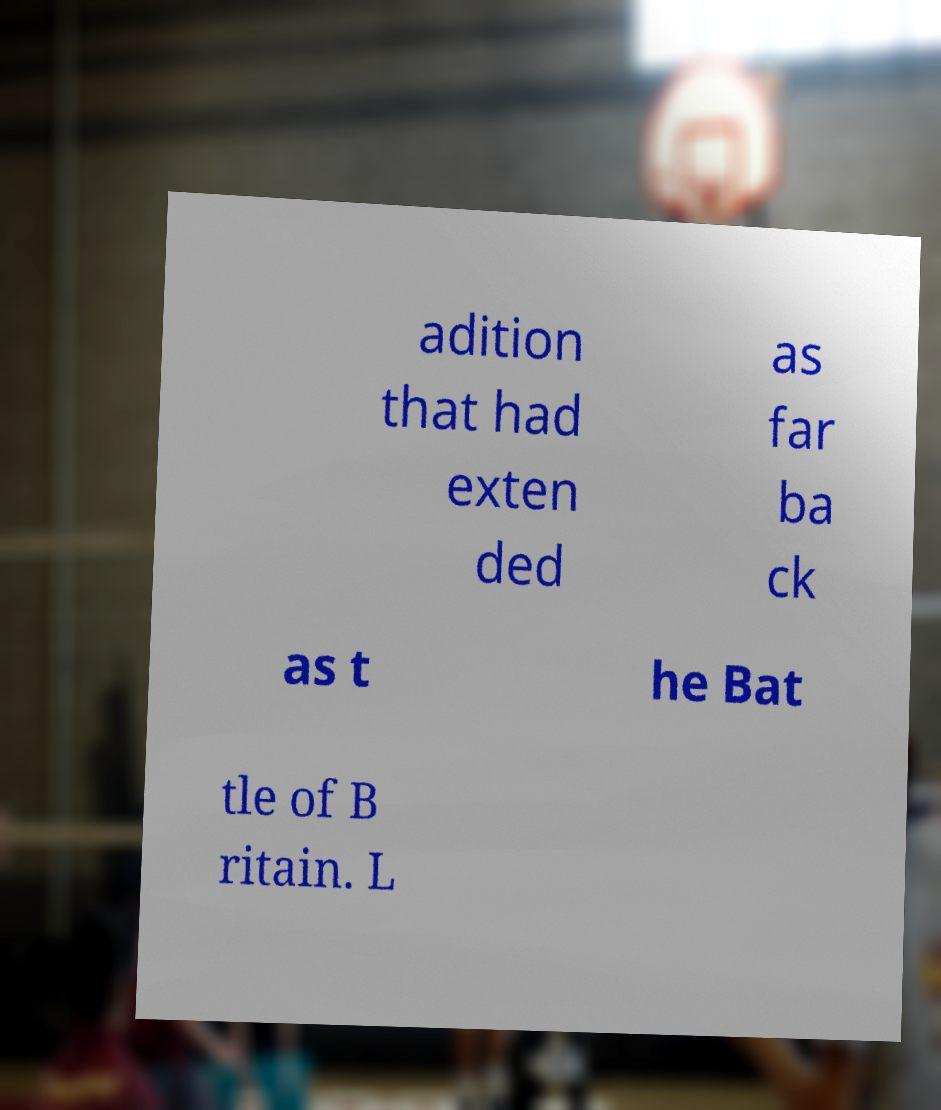There's text embedded in this image that I need extracted. Can you transcribe it verbatim? adition that had exten ded as far ba ck as t he Bat tle of B ritain. L 